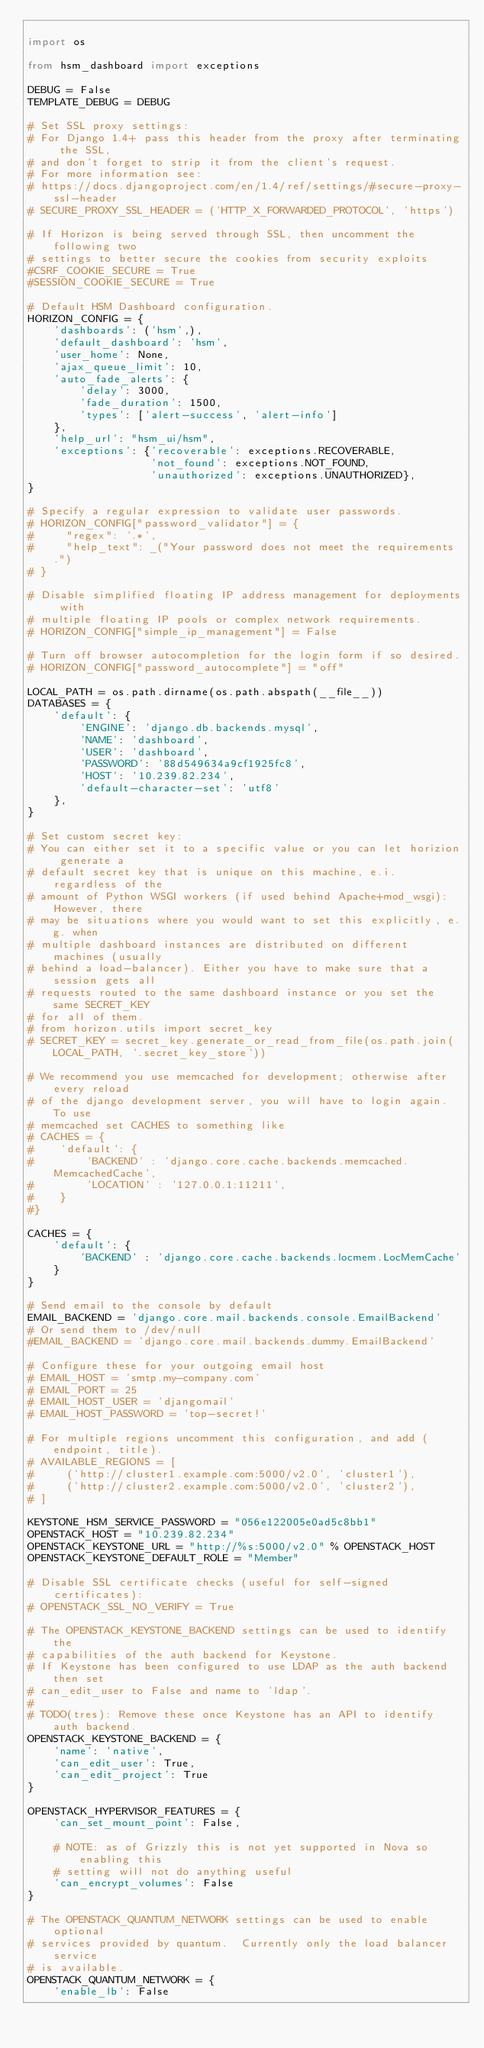<code> <loc_0><loc_0><loc_500><loc_500><_Python_>
import os

from hsm_dashboard import exceptions

DEBUG = False
TEMPLATE_DEBUG = DEBUG

# Set SSL proxy settings:
# For Django 1.4+ pass this header from the proxy after terminating the SSL,
# and don't forget to strip it from the client's request.
# For more information see:
# https://docs.djangoproject.com/en/1.4/ref/settings/#secure-proxy-ssl-header
# SECURE_PROXY_SSL_HEADER = ('HTTP_X_FORWARDED_PROTOCOL', 'https')

# If Horizon is being served through SSL, then uncomment the following two
# settings to better secure the cookies from security exploits
#CSRF_COOKIE_SECURE = True
#SESSION_COOKIE_SECURE = True

# Default HSM Dashboard configuration.
HORIZON_CONFIG = {
    'dashboards': ('hsm',),
    'default_dashboard': 'hsm',
    'user_home': None,
    'ajax_queue_limit': 10,
    'auto_fade_alerts': {
        'delay': 3000,
        'fade_duration': 1500,
        'types': ['alert-success', 'alert-info']
    },
    'help_url': "hsm_ui/hsm",
    'exceptions': {'recoverable': exceptions.RECOVERABLE,
                   'not_found': exceptions.NOT_FOUND,
                   'unauthorized': exceptions.UNAUTHORIZED},
}

# Specify a regular expression to validate user passwords.
# HORIZON_CONFIG["password_validator"] = {
#     "regex": '.*',
#     "help_text": _("Your password does not meet the requirements.")
# }

# Disable simplified floating IP address management for deployments with
# multiple floating IP pools or complex network requirements.
# HORIZON_CONFIG["simple_ip_management"] = False

# Turn off browser autocompletion for the login form if so desired.
# HORIZON_CONFIG["password_autocomplete"] = "off"

LOCAL_PATH = os.path.dirname(os.path.abspath(__file__))
DATABASES = {
    'default': {
        'ENGINE': 'django.db.backends.mysql',
        'NAME': 'dashboard',
        'USER': 'dashboard',
        'PASSWORD': '88d549634a9cf1925fc8',
        'HOST': '10.239.82.234',
        'default-character-set': 'utf8'
    },
}

# Set custom secret key:
# You can either set it to a specific value or you can let horizion generate a
# default secret key that is unique on this machine, e.i. regardless of the
# amount of Python WSGI workers (if used behind Apache+mod_wsgi): However, there
# may be situations where you would want to set this explicitly, e.g. when
# multiple dashboard instances are distributed on different machines (usually
# behind a load-balancer). Either you have to make sure that a session gets all
# requests routed to the same dashboard instance or you set the same SECRET_KEY
# for all of them.
# from horizon.utils import secret_key
# SECRET_KEY = secret_key.generate_or_read_from_file(os.path.join(LOCAL_PATH, '.secret_key_store'))

# We recommend you use memcached for development; otherwise after every reload
# of the django development server, you will have to login again. To use
# memcached set CACHES to something like
# CACHES = {
#    'default': {
#        'BACKEND' : 'django.core.cache.backends.memcached.MemcachedCache',
#        'LOCATION' : '127.0.0.1:11211',
#    }
#}

CACHES = {
    'default': {
        'BACKEND' : 'django.core.cache.backends.locmem.LocMemCache'
    }
}

# Send email to the console by default
EMAIL_BACKEND = 'django.core.mail.backends.console.EmailBackend'
# Or send them to /dev/null
#EMAIL_BACKEND = 'django.core.mail.backends.dummy.EmailBackend'

# Configure these for your outgoing email host
# EMAIL_HOST = 'smtp.my-company.com'
# EMAIL_PORT = 25
# EMAIL_HOST_USER = 'djangomail'
# EMAIL_HOST_PASSWORD = 'top-secret!'

# For multiple regions uncomment this configuration, and add (endpoint, title).
# AVAILABLE_REGIONS = [
#     ('http://cluster1.example.com:5000/v2.0', 'cluster1'),
#     ('http://cluster2.example.com:5000/v2.0', 'cluster2'),
# ]

KEYSTONE_HSM_SERVICE_PASSWORD = "056e122005e0ad5c8bb1"
OPENSTACK_HOST = "10.239.82.234"
OPENSTACK_KEYSTONE_URL = "http://%s:5000/v2.0" % OPENSTACK_HOST
OPENSTACK_KEYSTONE_DEFAULT_ROLE = "Member"

# Disable SSL certificate checks (useful for self-signed certificates):
# OPENSTACK_SSL_NO_VERIFY = True

# The OPENSTACK_KEYSTONE_BACKEND settings can be used to identify the
# capabilities of the auth backend for Keystone.
# If Keystone has been configured to use LDAP as the auth backend then set
# can_edit_user to False and name to 'ldap'.
#
# TODO(tres): Remove these once Keystone has an API to identify auth backend.
OPENSTACK_KEYSTONE_BACKEND = {
    'name': 'native',
    'can_edit_user': True,
    'can_edit_project': True
}

OPENSTACK_HYPERVISOR_FEATURES = {
    'can_set_mount_point': False,

    # NOTE: as of Grizzly this is not yet supported in Nova so enabling this
    # setting will not do anything useful
    'can_encrypt_volumes': False
}

# The OPENSTACK_QUANTUM_NETWORK settings can be used to enable optional
# services provided by quantum.  Currently only the load balancer service
# is available.
OPENSTACK_QUANTUM_NETWORK = {
    'enable_lb': False</code> 